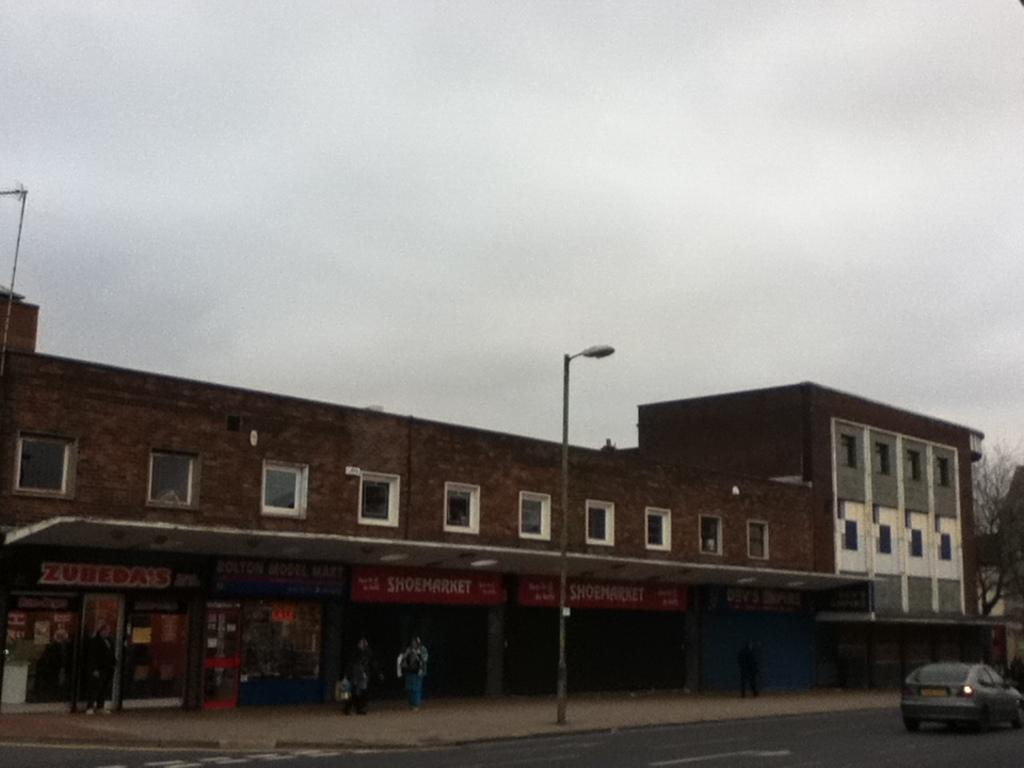In one or two sentences, can you explain what this image depicts? In this image I can see the vehicle on the road. To the side of the road I can see the light pole and the building with windows. I can see few people standing and few boards to the building. In the background I can see the sky. 